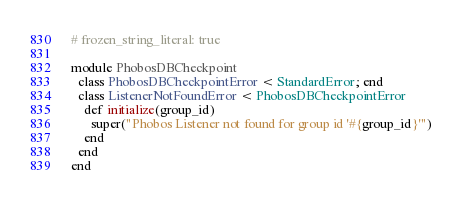<code> <loc_0><loc_0><loc_500><loc_500><_Ruby_># frozen_string_literal: true

module PhobosDBCheckpoint
  class PhobosDBCheckpointError < StandardError; end
  class ListenerNotFoundError < PhobosDBCheckpointError
    def initialize(group_id)
      super("Phobos Listener not found for group id '#{group_id}'")
    end
  end
end
</code> 